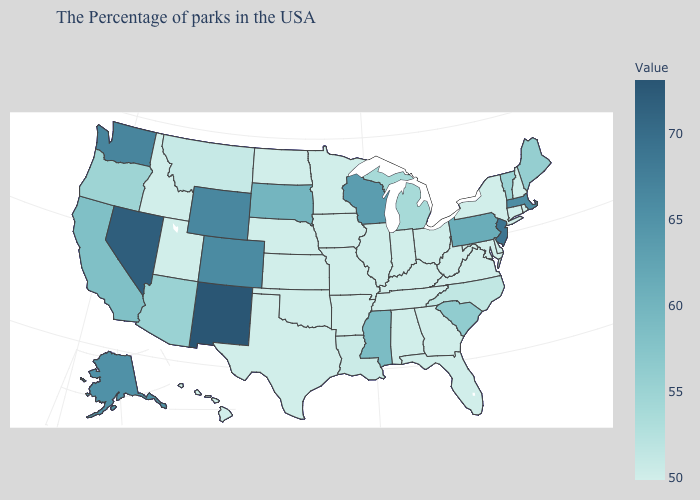Does Mississippi have the highest value in the South?
Answer briefly. Yes. Which states have the lowest value in the South?
Short answer required. Delaware, Maryland, Virginia, West Virginia, Florida, Georgia, Kentucky, Alabama, Tennessee, Arkansas, Oklahoma, Texas. Which states hav the highest value in the South?
Keep it brief. Mississippi. Does the map have missing data?
Quick response, please. No. Which states have the highest value in the USA?
Answer briefly. New Mexico. Which states hav the highest value in the Northeast?
Keep it brief. New Jersey. Among the states that border Maryland , which have the highest value?
Be succinct. Pennsylvania. 